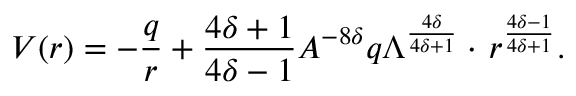Convert formula to latex. <formula><loc_0><loc_0><loc_500><loc_500>V ( r ) = - \frac { q } { r } + \frac { 4 \delta + 1 } { 4 \delta - 1 } A ^ { - 8 \delta } q \Lambda ^ { \frac { 4 \delta } { 4 \delta + 1 } } \cdot \, r ^ { \frac { 4 \delta - 1 } { 4 \delta + 1 } } .</formula> 